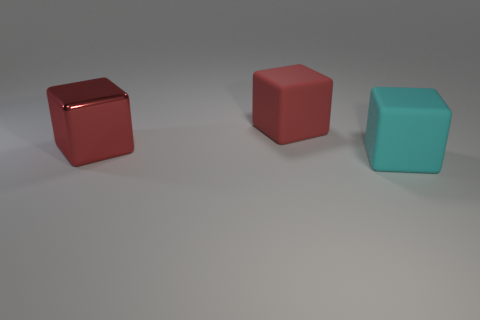There is another thing that is the same color as the metal thing; what material is it?
Your answer should be very brief. Rubber. Are any cyan blocks visible?
Offer a terse response. Yes. There is a large cube that is right of the matte cube that is on the left side of the cyan rubber block; how many large red rubber blocks are on the left side of it?
Offer a very short reply. 1. Is the shape of the cyan thing the same as the red object that is to the right of the red metal block?
Your response must be concise. Yes. Are there more big red metallic balls than large red rubber blocks?
Provide a short and direct response. No. There is a matte thing that is behind the large cyan thing; is it the same shape as the cyan rubber object?
Make the answer very short. Yes. Are there more big cubes that are behind the big cyan rubber thing than big red rubber blocks?
Your answer should be very brief. Yes. There is a large rubber thing that is on the left side of the big object in front of the large red metallic cube; what color is it?
Your response must be concise. Red. What number of tiny brown cubes are there?
Offer a terse response. 0. How many blocks are both left of the large cyan thing and right of the large red shiny cube?
Offer a very short reply. 1. 